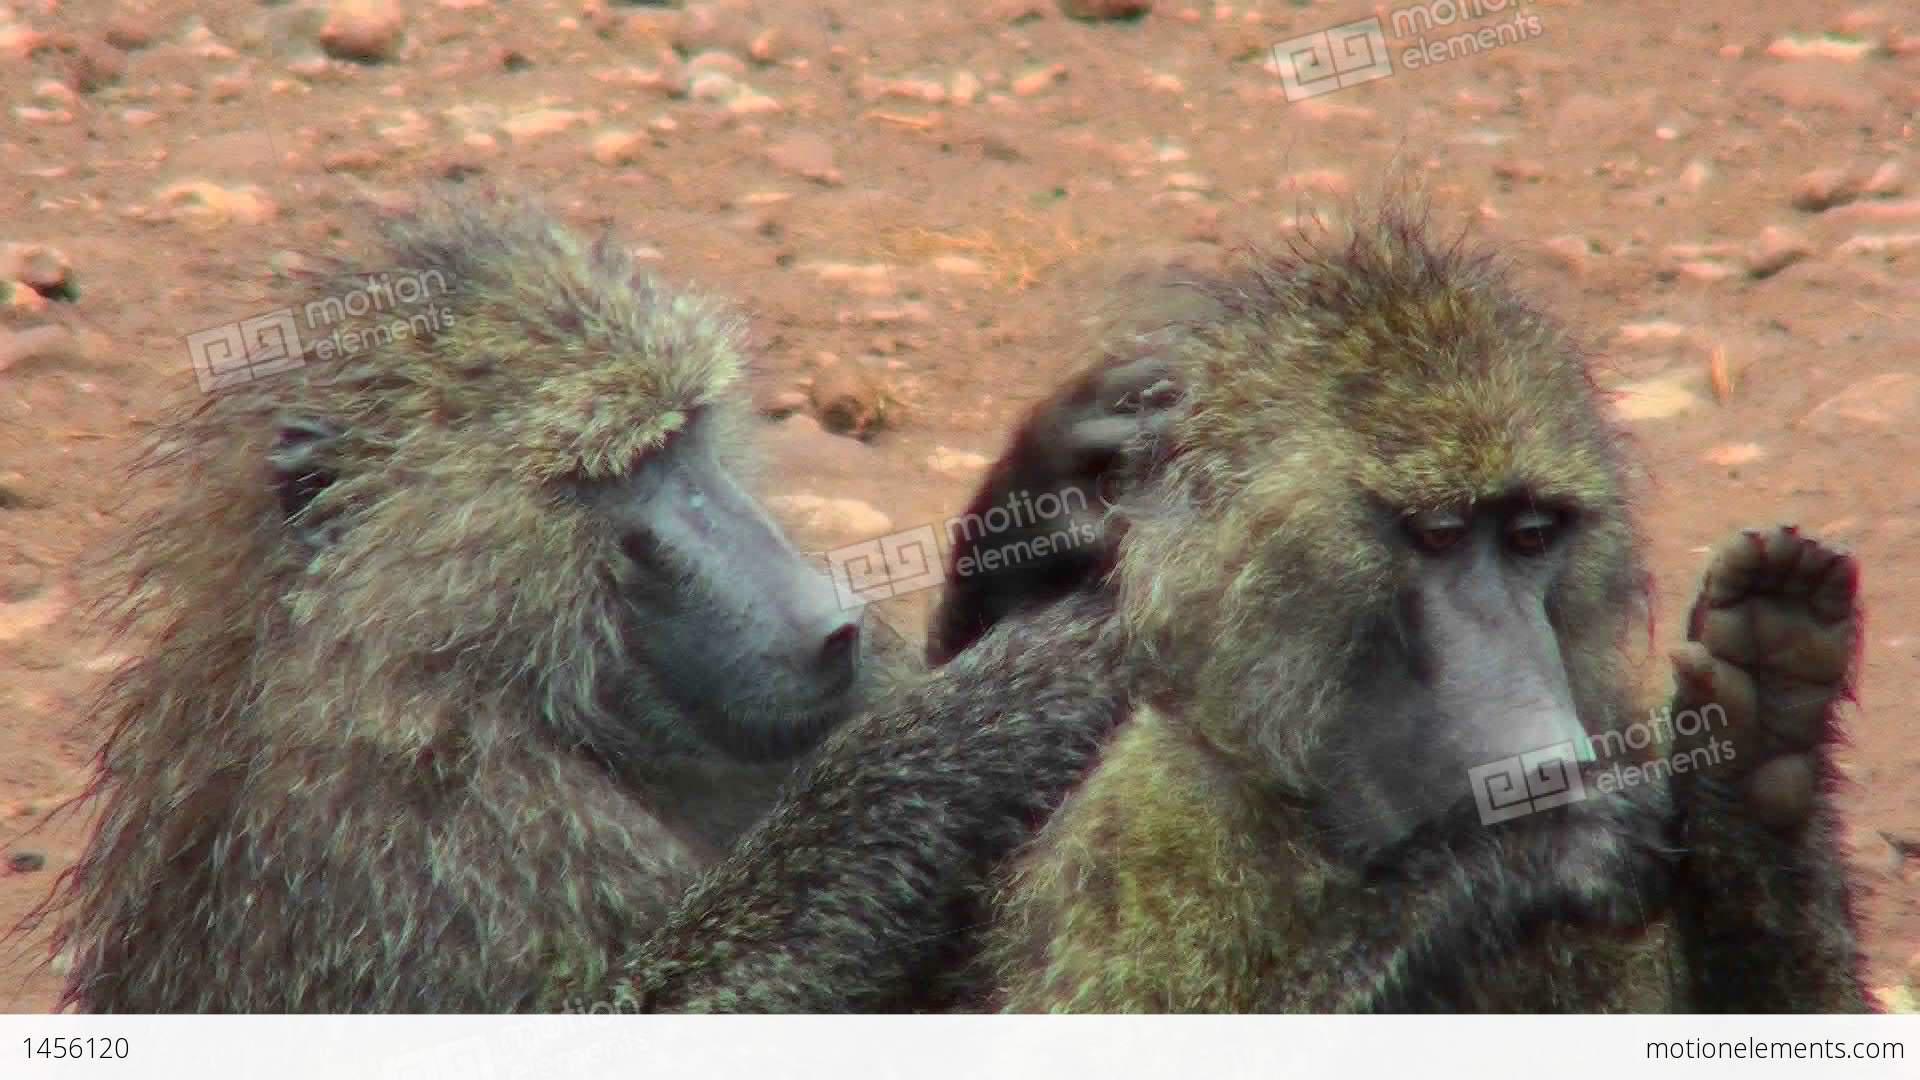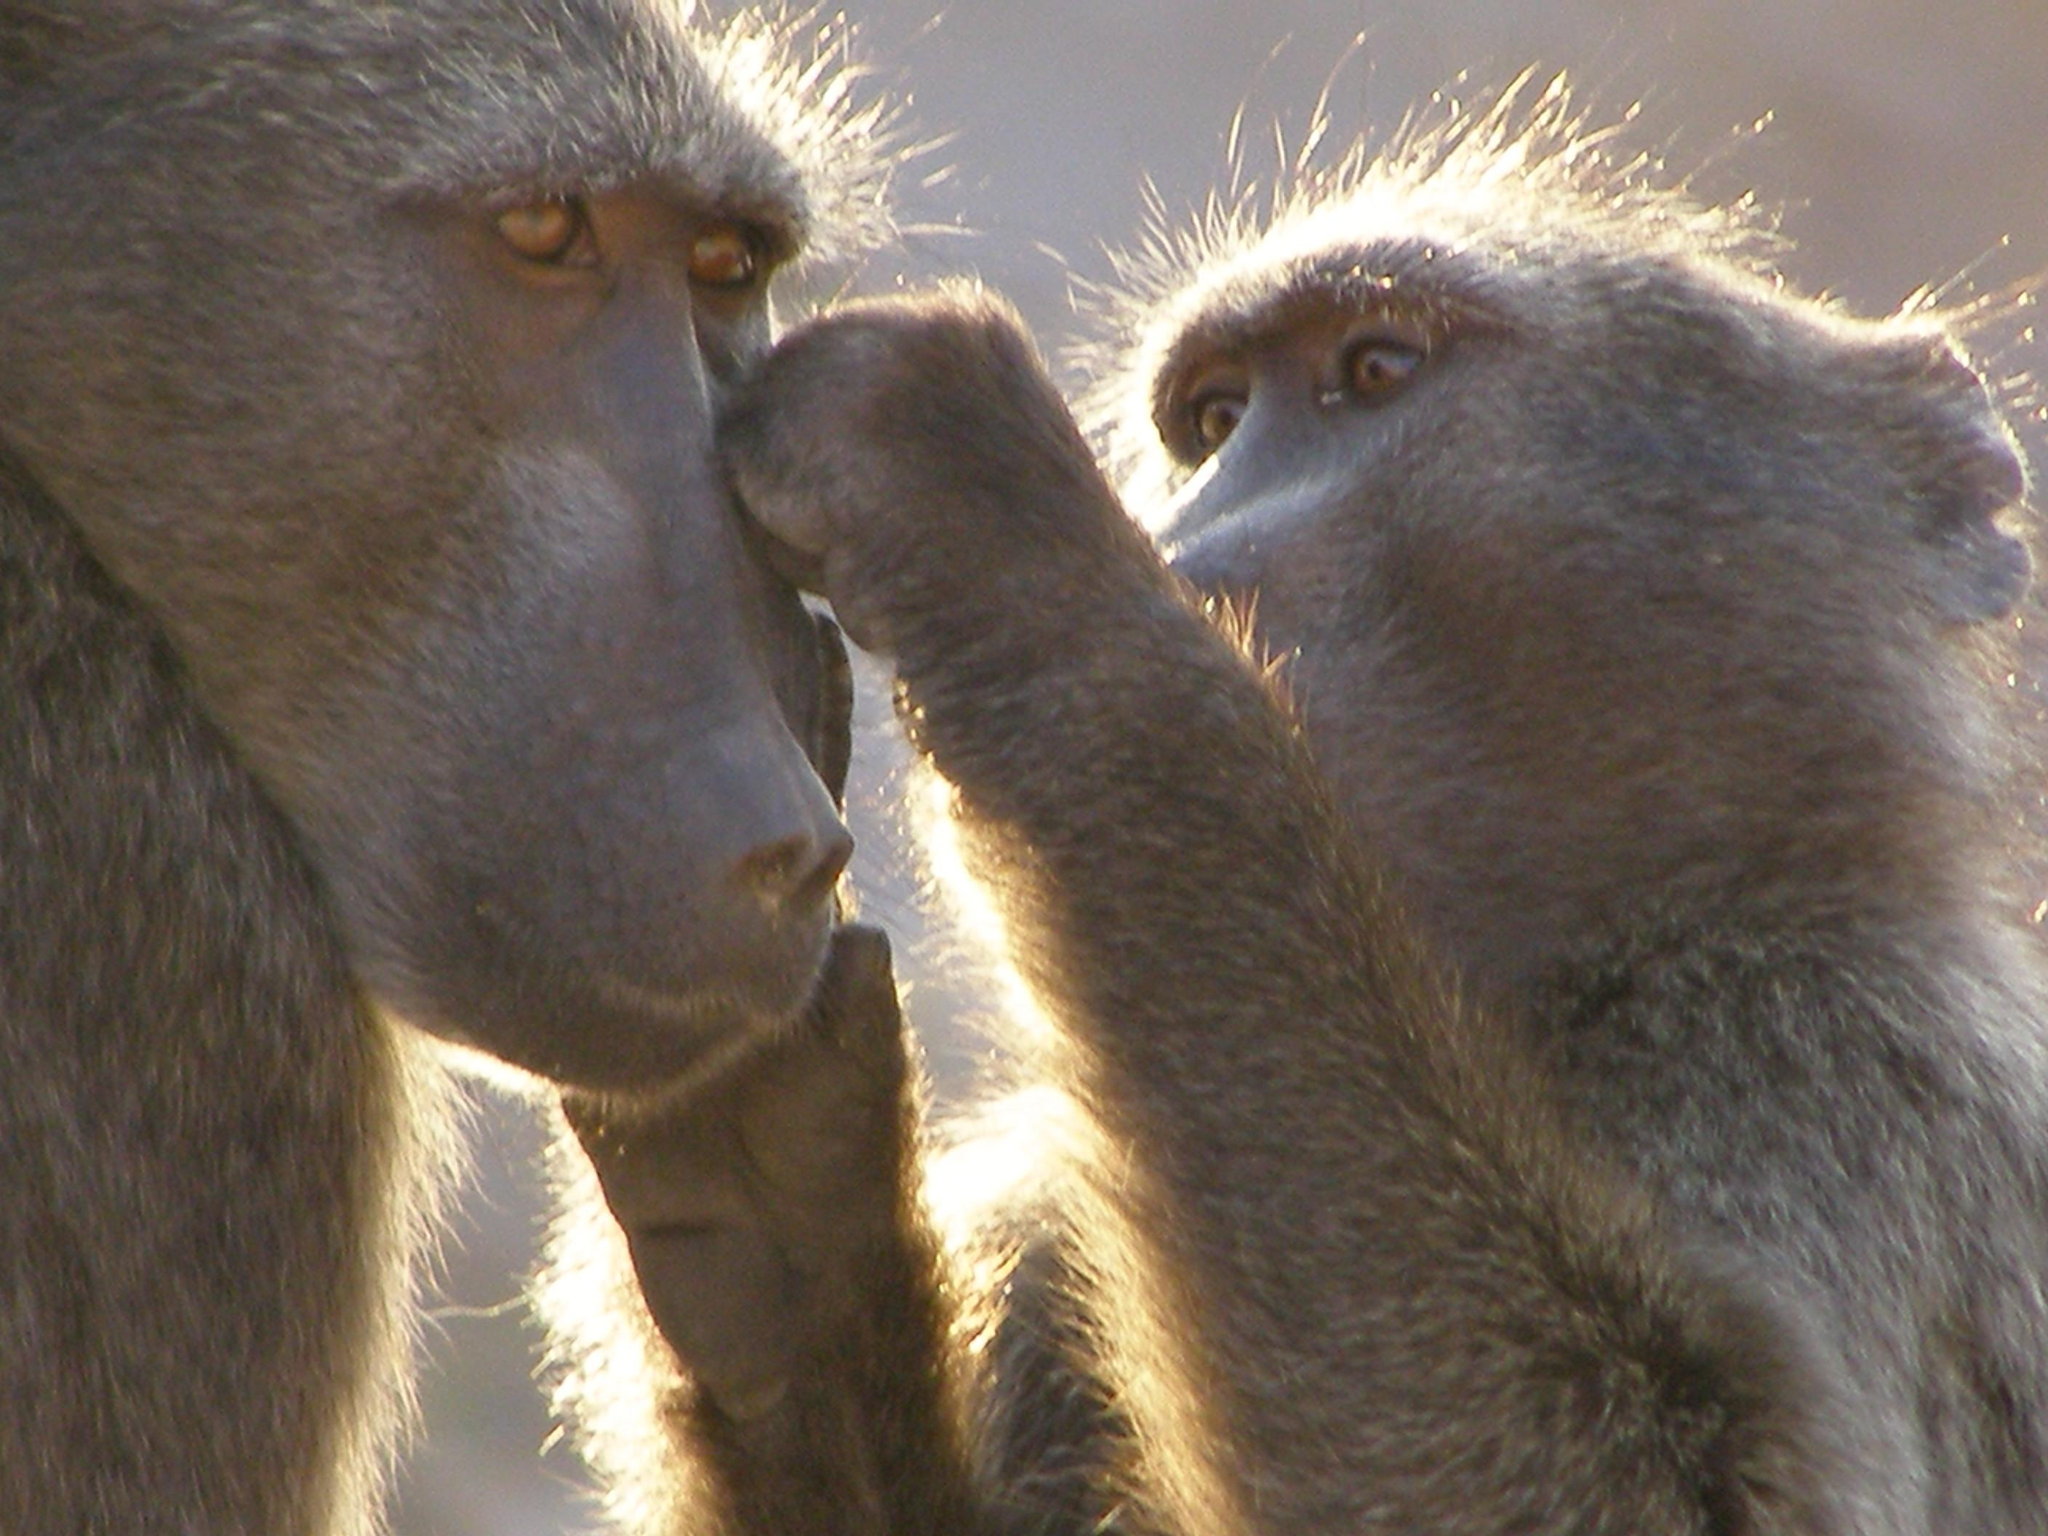The first image is the image on the left, the second image is the image on the right. Evaluate the accuracy of this statement regarding the images: "Both images contains an animal with both of its hands touching another animal in the head and neck area.". Is it true? Answer yes or no. Yes. The first image is the image on the left, the second image is the image on the right. For the images shown, is this caption "The monkey on the right is grooming the face of the monkey on the left." true? Answer yes or no. Yes. 